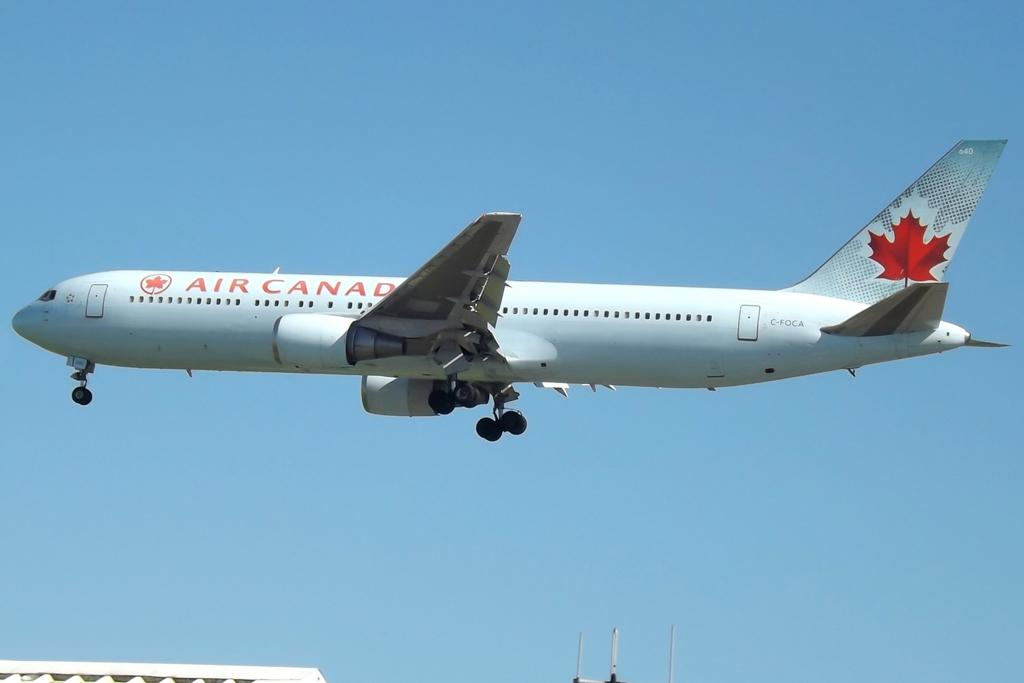<image>
Relay a brief, clear account of the picture shown. A jet plane from Air Canada is flying through the air 